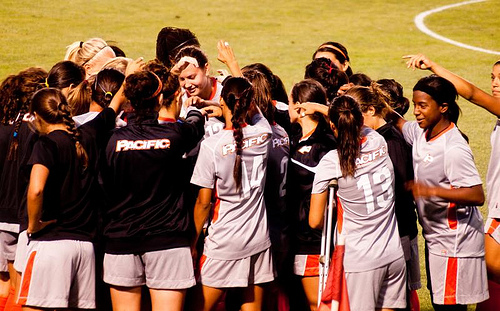<image>
Is there a stripe under the shorts? No. The stripe is not positioned under the shorts. The vertical relationship between these objects is different. 